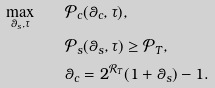<formula> <loc_0><loc_0><loc_500><loc_500>\max _ { \theta _ { s } , \tau } \quad & \mathcal { P } _ { c } ( \theta _ { c } , \tau ) , \\ \quad & \mathcal { P } _ { s } ( \theta _ { s } , \tau ) \geq \mathcal { P } _ { T } , \\ & \theta _ { c } = 2 ^ { \mathcal { R } _ { T } } ( 1 + \theta _ { s } ) - 1 .</formula> 